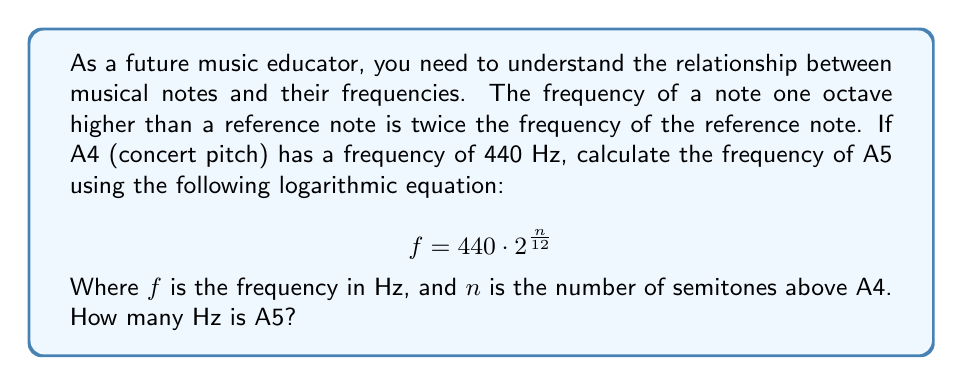Can you solve this math problem? To solve this problem, we need to follow these steps:

1. Understand the given information:
   - A4 (reference note) has a frequency of 440 Hz
   - A5 is one octave higher than A4
   - The equation relating frequency to semitones is $f = 440 \cdot 2^{\frac{n}{12}}$

2. Determine the number of semitones between A4 and A5:
   - There are 12 semitones in an octave
   - Therefore, $n = 12$

3. Substitute the values into the equation:
   $$ f = 440 \cdot 2^{\frac{12}{12}} $$

4. Simplify the exponent:
   $$ f = 440 \cdot 2^1 $$

5. Calculate the result:
   $$ f = 440 \cdot 2 = 880 $$

Thus, the frequency of A5 is 880 Hz, which is exactly twice the frequency of A4 (440 Hz), confirming that A5 is indeed one octave higher than A4.
Answer: 880 Hz 